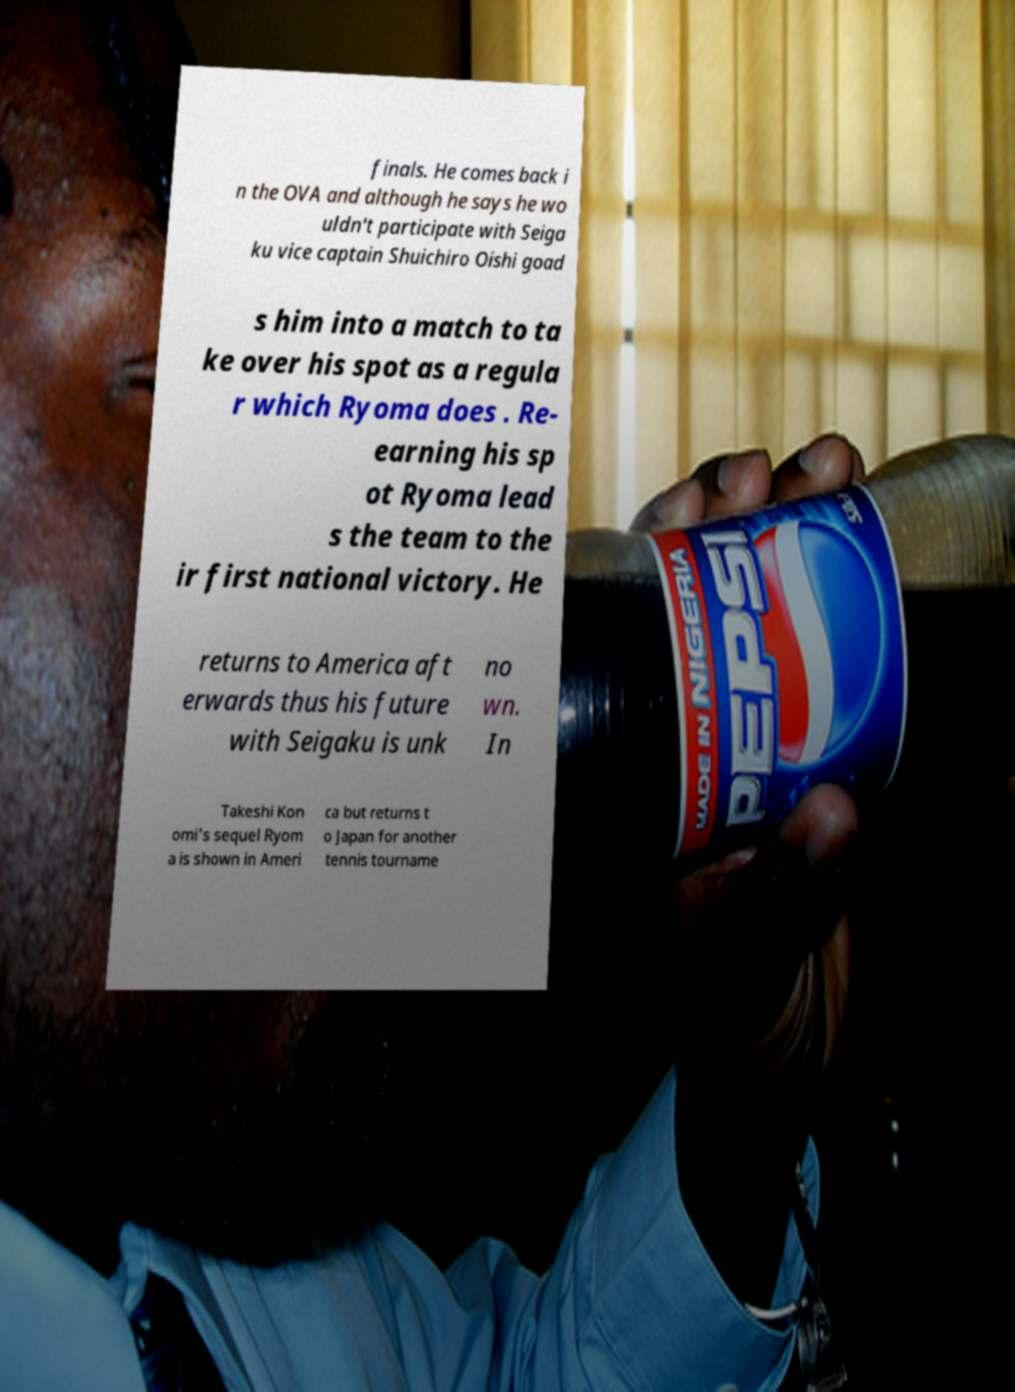I need the written content from this picture converted into text. Can you do that? finals. He comes back i n the OVA and although he says he wo uldn't participate with Seiga ku vice captain Shuichiro Oishi goad s him into a match to ta ke over his spot as a regula r which Ryoma does . Re- earning his sp ot Ryoma lead s the team to the ir first national victory. He returns to America aft erwards thus his future with Seigaku is unk no wn. In Takeshi Kon omi's sequel Ryom a is shown in Ameri ca but returns t o Japan for another tennis tourname 